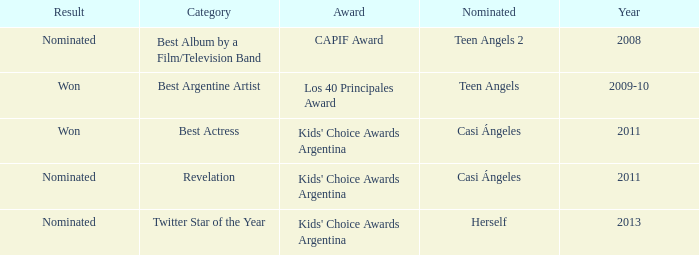What year saw an award in the category of Revelation? 2011.0. 